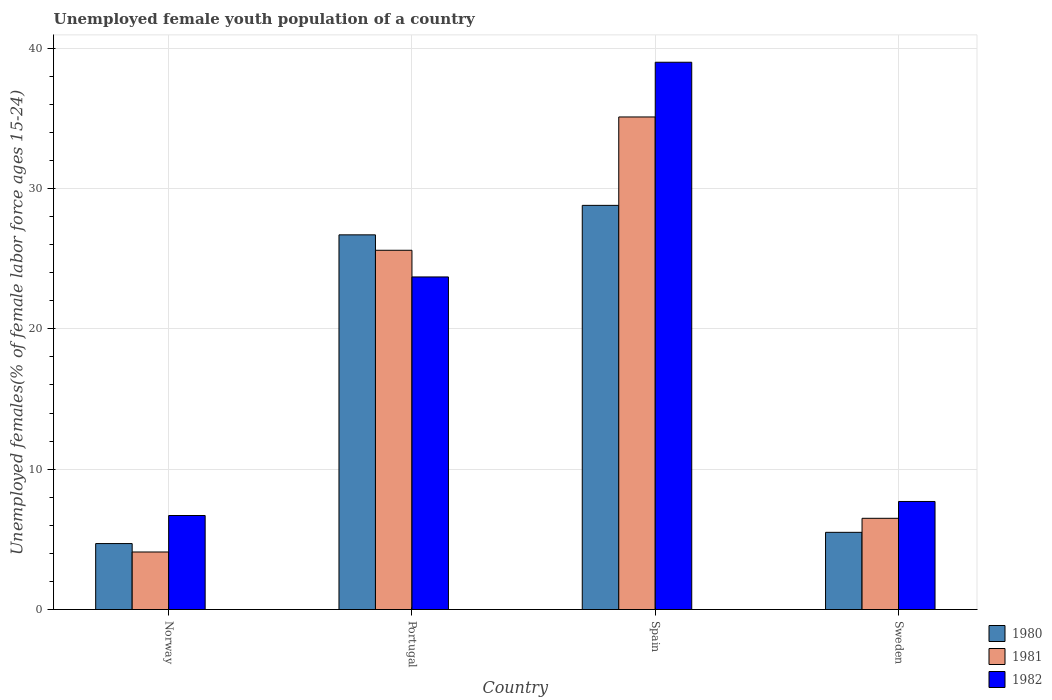Are the number of bars per tick equal to the number of legend labels?
Give a very brief answer. Yes. Are the number of bars on each tick of the X-axis equal?
Offer a very short reply. Yes. How many bars are there on the 3rd tick from the right?
Your answer should be compact. 3. What is the percentage of unemployed female youth population in 1982 in Portugal?
Keep it short and to the point. 23.7. Across all countries, what is the maximum percentage of unemployed female youth population in 1980?
Provide a succinct answer. 28.8. Across all countries, what is the minimum percentage of unemployed female youth population in 1980?
Your answer should be compact. 4.7. In which country was the percentage of unemployed female youth population in 1981 minimum?
Offer a very short reply. Norway. What is the total percentage of unemployed female youth population in 1980 in the graph?
Make the answer very short. 65.7. What is the difference between the percentage of unemployed female youth population in 1982 in Portugal and that in Spain?
Give a very brief answer. -15.3. What is the difference between the percentage of unemployed female youth population in 1981 in Norway and the percentage of unemployed female youth population in 1982 in Portugal?
Offer a terse response. -19.6. What is the average percentage of unemployed female youth population in 1982 per country?
Offer a very short reply. 19.28. What is the difference between the percentage of unemployed female youth population of/in 1980 and percentage of unemployed female youth population of/in 1981 in Spain?
Offer a very short reply. -6.3. What is the ratio of the percentage of unemployed female youth population in 1980 in Norway to that in Sweden?
Make the answer very short. 0.85. Is the percentage of unemployed female youth population in 1982 in Portugal less than that in Spain?
Offer a terse response. Yes. What is the difference between the highest and the second highest percentage of unemployed female youth population in 1981?
Provide a succinct answer. -9.5. What is the difference between the highest and the lowest percentage of unemployed female youth population in 1981?
Your answer should be very brief. 31. In how many countries, is the percentage of unemployed female youth population in 1982 greater than the average percentage of unemployed female youth population in 1982 taken over all countries?
Ensure brevity in your answer.  2. What does the 2nd bar from the left in Norway represents?
Offer a very short reply. 1981. Is it the case that in every country, the sum of the percentage of unemployed female youth population in 1982 and percentage of unemployed female youth population in 1980 is greater than the percentage of unemployed female youth population in 1981?
Offer a terse response. Yes. How many bars are there?
Offer a very short reply. 12. Does the graph contain grids?
Provide a succinct answer. Yes. How many legend labels are there?
Provide a short and direct response. 3. What is the title of the graph?
Your answer should be compact. Unemployed female youth population of a country. Does "1964" appear as one of the legend labels in the graph?
Offer a terse response. No. What is the label or title of the Y-axis?
Keep it short and to the point. Unemployed females(% of female labor force ages 15-24). What is the Unemployed females(% of female labor force ages 15-24) of 1980 in Norway?
Give a very brief answer. 4.7. What is the Unemployed females(% of female labor force ages 15-24) of 1981 in Norway?
Your response must be concise. 4.1. What is the Unemployed females(% of female labor force ages 15-24) in 1982 in Norway?
Your answer should be very brief. 6.7. What is the Unemployed females(% of female labor force ages 15-24) in 1980 in Portugal?
Your answer should be very brief. 26.7. What is the Unemployed females(% of female labor force ages 15-24) of 1981 in Portugal?
Offer a very short reply. 25.6. What is the Unemployed females(% of female labor force ages 15-24) in 1982 in Portugal?
Ensure brevity in your answer.  23.7. What is the Unemployed females(% of female labor force ages 15-24) in 1980 in Spain?
Provide a short and direct response. 28.8. What is the Unemployed females(% of female labor force ages 15-24) of 1981 in Spain?
Ensure brevity in your answer.  35.1. What is the Unemployed females(% of female labor force ages 15-24) of 1981 in Sweden?
Your answer should be very brief. 6.5. What is the Unemployed females(% of female labor force ages 15-24) in 1982 in Sweden?
Your answer should be compact. 7.7. Across all countries, what is the maximum Unemployed females(% of female labor force ages 15-24) of 1980?
Offer a terse response. 28.8. Across all countries, what is the maximum Unemployed females(% of female labor force ages 15-24) in 1981?
Make the answer very short. 35.1. Across all countries, what is the minimum Unemployed females(% of female labor force ages 15-24) in 1980?
Give a very brief answer. 4.7. Across all countries, what is the minimum Unemployed females(% of female labor force ages 15-24) of 1981?
Your answer should be compact. 4.1. Across all countries, what is the minimum Unemployed females(% of female labor force ages 15-24) of 1982?
Your response must be concise. 6.7. What is the total Unemployed females(% of female labor force ages 15-24) in 1980 in the graph?
Give a very brief answer. 65.7. What is the total Unemployed females(% of female labor force ages 15-24) of 1981 in the graph?
Your answer should be compact. 71.3. What is the total Unemployed females(% of female labor force ages 15-24) of 1982 in the graph?
Ensure brevity in your answer.  77.1. What is the difference between the Unemployed females(% of female labor force ages 15-24) in 1981 in Norway and that in Portugal?
Keep it short and to the point. -21.5. What is the difference between the Unemployed females(% of female labor force ages 15-24) in 1982 in Norway and that in Portugal?
Ensure brevity in your answer.  -17. What is the difference between the Unemployed females(% of female labor force ages 15-24) of 1980 in Norway and that in Spain?
Keep it short and to the point. -24.1. What is the difference between the Unemployed females(% of female labor force ages 15-24) of 1981 in Norway and that in Spain?
Make the answer very short. -31. What is the difference between the Unemployed females(% of female labor force ages 15-24) in 1982 in Norway and that in Spain?
Your answer should be compact. -32.3. What is the difference between the Unemployed females(% of female labor force ages 15-24) in 1980 in Norway and that in Sweden?
Your answer should be very brief. -0.8. What is the difference between the Unemployed females(% of female labor force ages 15-24) of 1981 in Norway and that in Sweden?
Your answer should be compact. -2.4. What is the difference between the Unemployed females(% of female labor force ages 15-24) in 1982 in Portugal and that in Spain?
Keep it short and to the point. -15.3. What is the difference between the Unemployed females(% of female labor force ages 15-24) of 1980 in Portugal and that in Sweden?
Provide a short and direct response. 21.2. What is the difference between the Unemployed females(% of female labor force ages 15-24) of 1980 in Spain and that in Sweden?
Keep it short and to the point. 23.3. What is the difference between the Unemployed females(% of female labor force ages 15-24) in 1981 in Spain and that in Sweden?
Make the answer very short. 28.6. What is the difference between the Unemployed females(% of female labor force ages 15-24) of 1982 in Spain and that in Sweden?
Provide a short and direct response. 31.3. What is the difference between the Unemployed females(% of female labor force ages 15-24) in 1980 in Norway and the Unemployed females(% of female labor force ages 15-24) in 1981 in Portugal?
Your answer should be very brief. -20.9. What is the difference between the Unemployed females(% of female labor force ages 15-24) in 1980 in Norway and the Unemployed females(% of female labor force ages 15-24) in 1982 in Portugal?
Ensure brevity in your answer.  -19. What is the difference between the Unemployed females(% of female labor force ages 15-24) in 1981 in Norway and the Unemployed females(% of female labor force ages 15-24) in 1982 in Portugal?
Provide a succinct answer. -19.6. What is the difference between the Unemployed females(% of female labor force ages 15-24) of 1980 in Norway and the Unemployed females(% of female labor force ages 15-24) of 1981 in Spain?
Your answer should be compact. -30.4. What is the difference between the Unemployed females(% of female labor force ages 15-24) in 1980 in Norway and the Unemployed females(% of female labor force ages 15-24) in 1982 in Spain?
Your answer should be compact. -34.3. What is the difference between the Unemployed females(% of female labor force ages 15-24) of 1981 in Norway and the Unemployed females(% of female labor force ages 15-24) of 1982 in Spain?
Offer a very short reply. -34.9. What is the difference between the Unemployed females(% of female labor force ages 15-24) of 1980 in Norway and the Unemployed females(% of female labor force ages 15-24) of 1982 in Sweden?
Make the answer very short. -3. What is the difference between the Unemployed females(% of female labor force ages 15-24) in 1981 in Portugal and the Unemployed females(% of female labor force ages 15-24) in 1982 in Spain?
Offer a terse response. -13.4. What is the difference between the Unemployed females(% of female labor force ages 15-24) of 1980 in Portugal and the Unemployed females(% of female labor force ages 15-24) of 1981 in Sweden?
Provide a short and direct response. 20.2. What is the difference between the Unemployed females(% of female labor force ages 15-24) of 1980 in Spain and the Unemployed females(% of female labor force ages 15-24) of 1981 in Sweden?
Provide a short and direct response. 22.3. What is the difference between the Unemployed females(% of female labor force ages 15-24) in 1980 in Spain and the Unemployed females(% of female labor force ages 15-24) in 1982 in Sweden?
Offer a terse response. 21.1. What is the difference between the Unemployed females(% of female labor force ages 15-24) in 1981 in Spain and the Unemployed females(% of female labor force ages 15-24) in 1982 in Sweden?
Provide a short and direct response. 27.4. What is the average Unemployed females(% of female labor force ages 15-24) of 1980 per country?
Provide a succinct answer. 16.43. What is the average Unemployed females(% of female labor force ages 15-24) in 1981 per country?
Make the answer very short. 17.82. What is the average Unemployed females(% of female labor force ages 15-24) in 1982 per country?
Give a very brief answer. 19.27. What is the difference between the Unemployed females(% of female labor force ages 15-24) of 1980 and Unemployed females(% of female labor force ages 15-24) of 1981 in Norway?
Your answer should be very brief. 0.6. What is the difference between the Unemployed females(% of female labor force ages 15-24) of 1981 and Unemployed females(% of female labor force ages 15-24) of 1982 in Norway?
Offer a very short reply. -2.6. What is the difference between the Unemployed females(% of female labor force ages 15-24) in 1980 and Unemployed females(% of female labor force ages 15-24) in 1982 in Spain?
Your answer should be very brief. -10.2. What is the difference between the Unemployed females(% of female labor force ages 15-24) in 1981 and Unemployed females(% of female labor force ages 15-24) in 1982 in Spain?
Give a very brief answer. -3.9. What is the difference between the Unemployed females(% of female labor force ages 15-24) of 1980 and Unemployed females(% of female labor force ages 15-24) of 1981 in Sweden?
Offer a very short reply. -1. What is the difference between the Unemployed females(% of female labor force ages 15-24) in 1981 and Unemployed females(% of female labor force ages 15-24) in 1982 in Sweden?
Your answer should be very brief. -1.2. What is the ratio of the Unemployed females(% of female labor force ages 15-24) of 1980 in Norway to that in Portugal?
Your answer should be compact. 0.18. What is the ratio of the Unemployed females(% of female labor force ages 15-24) of 1981 in Norway to that in Portugal?
Keep it short and to the point. 0.16. What is the ratio of the Unemployed females(% of female labor force ages 15-24) in 1982 in Norway to that in Portugal?
Make the answer very short. 0.28. What is the ratio of the Unemployed females(% of female labor force ages 15-24) of 1980 in Norway to that in Spain?
Your response must be concise. 0.16. What is the ratio of the Unemployed females(% of female labor force ages 15-24) in 1981 in Norway to that in Spain?
Offer a terse response. 0.12. What is the ratio of the Unemployed females(% of female labor force ages 15-24) in 1982 in Norway to that in Spain?
Your answer should be compact. 0.17. What is the ratio of the Unemployed females(% of female labor force ages 15-24) of 1980 in Norway to that in Sweden?
Offer a very short reply. 0.85. What is the ratio of the Unemployed females(% of female labor force ages 15-24) in 1981 in Norway to that in Sweden?
Ensure brevity in your answer.  0.63. What is the ratio of the Unemployed females(% of female labor force ages 15-24) of 1982 in Norway to that in Sweden?
Ensure brevity in your answer.  0.87. What is the ratio of the Unemployed females(% of female labor force ages 15-24) of 1980 in Portugal to that in Spain?
Give a very brief answer. 0.93. What is the ratio of the Unemployed females(% of female labor force ages 15-24) of 1981 in Portugal to that in Spain?
Ensure brevity in your answer.  0.73. What is the ratio of the Unemployed females(% of female labor force ages 15-24) of 1982 in Portugal to that in Spain?
Your answer should be very brief. 0.61. What is the ratio of the Unemployed females(% of female labor force ages 15-24) of 1980 in Portugal to that in Sweden?
Ensure brevity in your answer.  4.85. What is the ratio of the Unemployed females(% of female labor force ages 15-24) of 1981 in Portugal to that in Sweden?
Ensure brevity in your answer.  3.94. What is the ratio of the Unemployed females(% of female labor force ages 15-24) of 1982 in Portugal to that in Sweden?
Your answer should be compact. 3.08. What is the ratio of the Unemployed females(% of female labor force ages 15-24) in 1980 in Spain to that in Sweden?
Your response must be concise. 5.24. What is the ratio of the Unemployed females(% of female labor force ages 15-24) in 1981 in Spain to that in Sweden?
Provide a short and direct response. 5.4. What is the ratio of the Unemployed females(% of female labor force ages 15-24) in 1982 in Spain to that in Sweden?
Provide a succinct answer. 5.06. What is the difference between the highest and the second highest Unemployed females(% of female labor force ages 15-24) of 1981?
Provide a succinct answer. 9.5. What is the difference between the highest and the second highest Unemployed females(% of female labor force ages 15-24) of 1982?
Provide a short and direct response. 15.3. What is the difference between the highest and the lowest Unemployed females(% of female labor force ages 15-24) of 1980?
Ensure brevity in your answer.  24.1. What is the difference between the highest and the lowest Unemployed females(% of female labor force ages 15-24) of 1982?
Offer a very short reply. 32.3. 